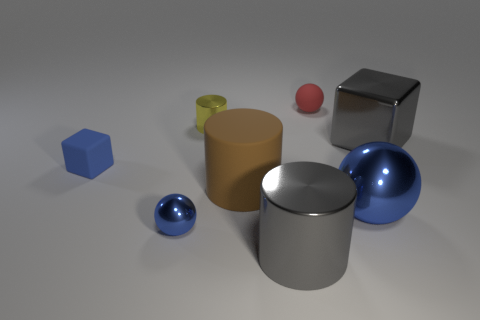Does the image show any exact duplicates in shape and color? Within the image, no two objects share an identical pairing of shape and color. Each object possesses a unique combination of geometry and hue, thereby negating the presence of exact visual duplicates. Can you describe the colors and the number of objects depicted? The scene comprises six objects distinct in color: a red sphere, a yellow cylinder, a blue hexahedron, a green truncated cone, and two metallic objects – a silver cube and a silver cylinder. Each has been rendered with a different color and exhibits a separate geometric form. 